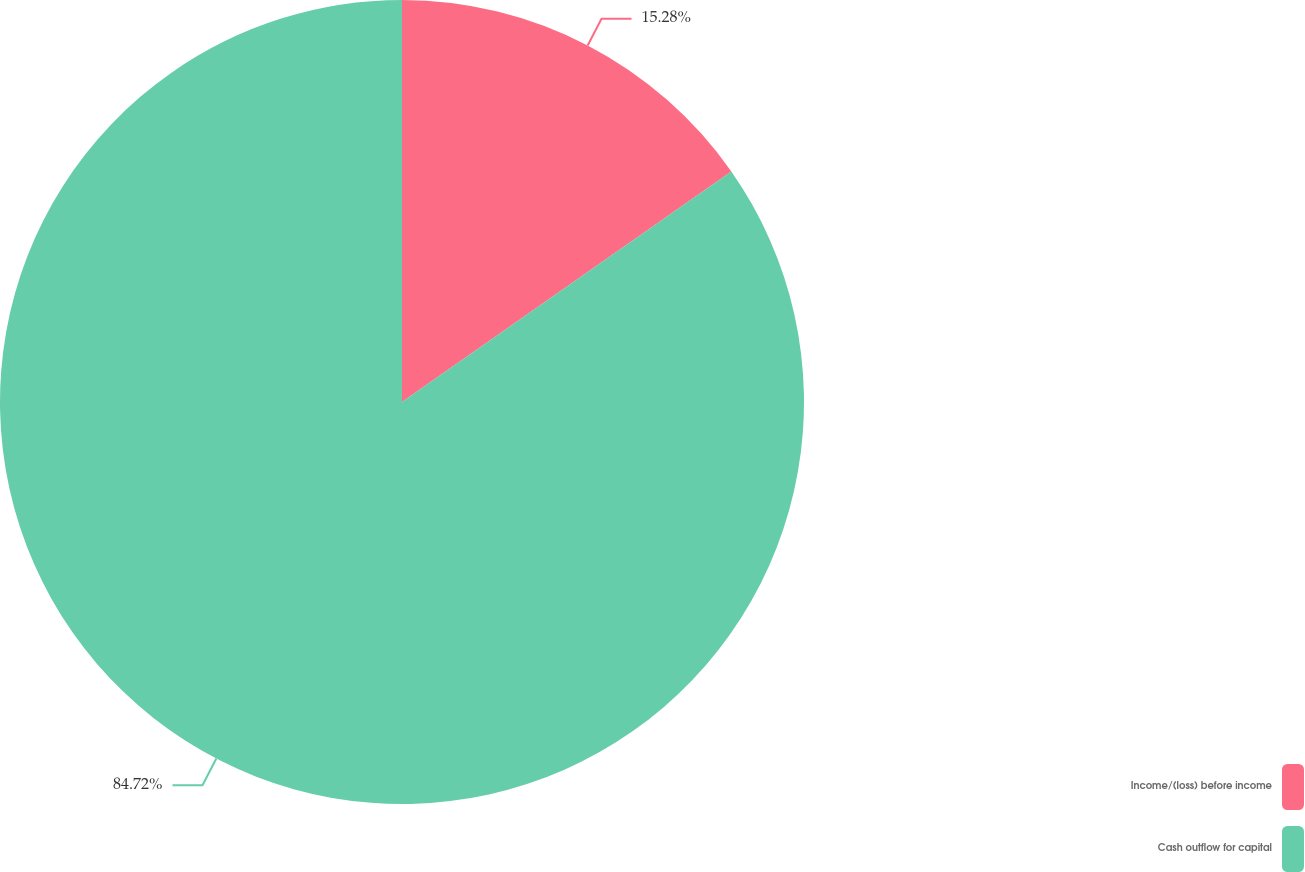Convert chart. <chart><loc_0><loc_0><loc_500><loc_500><pie_chart><fcel>Income/(loss) before income<fcel>Cash outflow for capital<nl><fcel>15.28%<fcel>84.72%<nl></chart> 